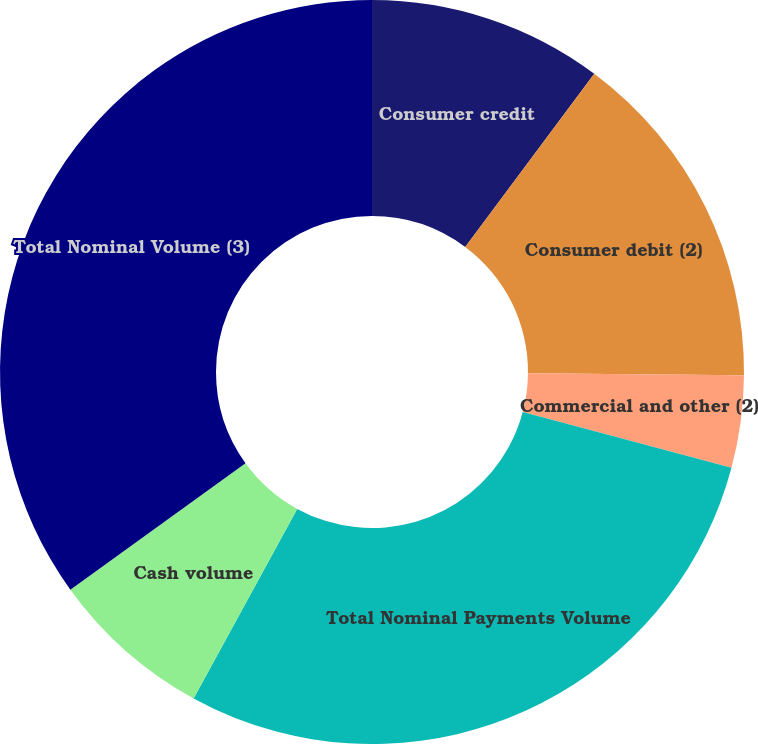<chart> <loc_0><loc_0><loc_500><loc_500><pie_chart><fcel>Consumer credit<fcel>Consumer debit (2)<fcel>Commercial and other (2)<fcel>Total Nominal Payments Volume<fcel>Cash volume<fcel>Total Nominal Volume (3)<nl><fcel>10.19%<fcel>14.95%<fcel>4.0%<fcel>28.82%<fcel>7.09%<fcel>34.95%<nl></chart> 